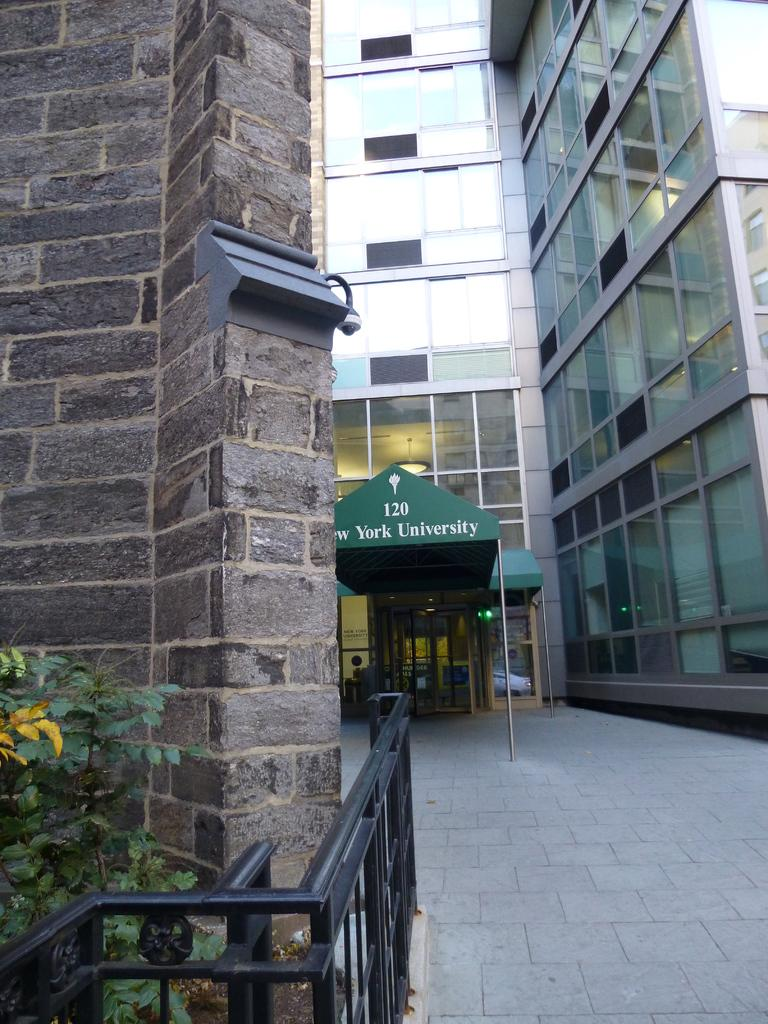What type of structure is present in the image? There is a building in the image. What is written on the building or nearby? Words and numbers are written in the image. What type of vegetation can be seen in the image? Leaves on stems are visible in the image. What type of barrier or divider is present in the image? There is a wall in the image. What type of surface is visible in the image? There is a path in the image. What type of lead is being used in the image? There is no lead present in the image. What type of apparatus is being used in the image? There is no apparatus present in the image. 